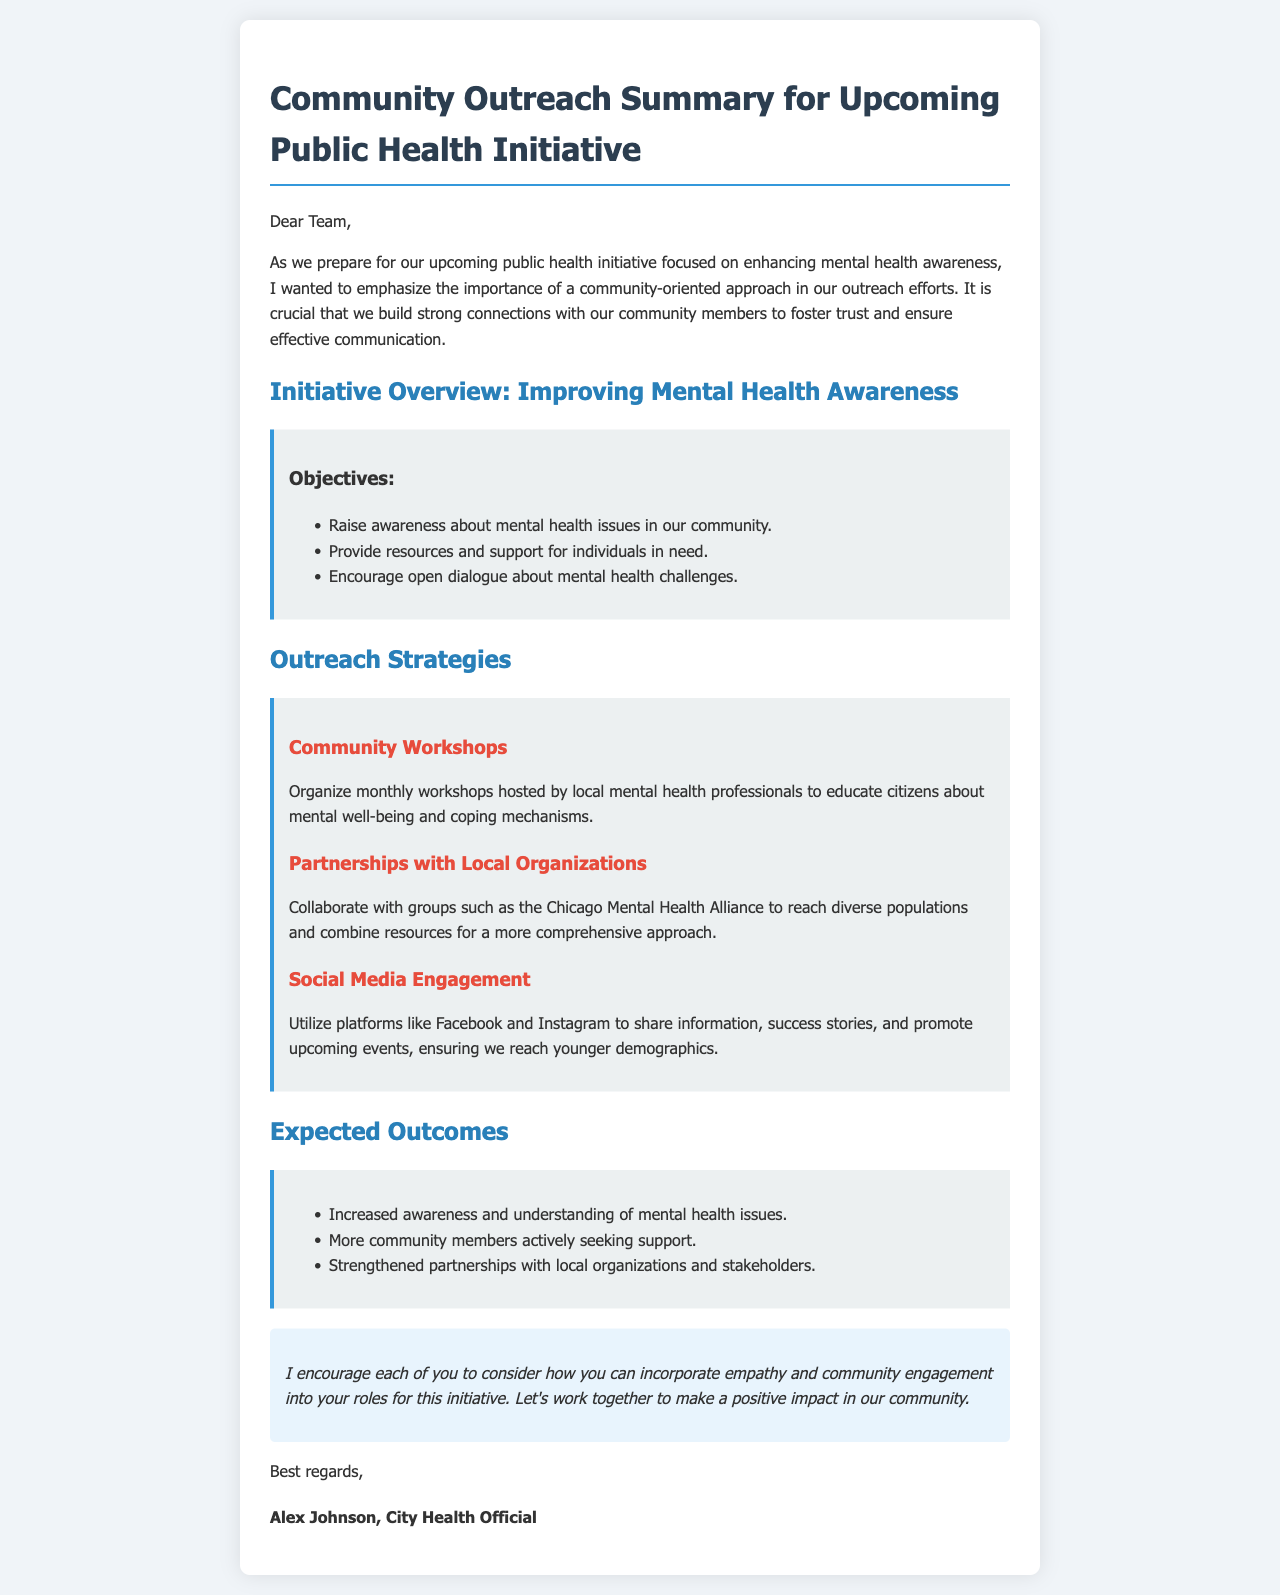What is the title of the initiative? The title of the initiative is specified in the document's header, which is "Community Outreach Summary for Upcoming Public Health Initiative."
Answer: Community Outreach Summary for Upcoming Public Health Initiative Who is the author of the email? The email's closing section contains the author's name, which identifies them as a city health official.
Answer: Alex Johnson What are the three objectives listed in the document? The objectives are detailed in a bullet point format under the "Objectives" section.
Answer: Raise awareness about mental health issues in our community What type of events will be organized monthly as part of outreach strategies? The outreach strategy mentions monthly events organized to educate citizens.
Answer: Community Workshops Which social media platforms are mentioned for engagement? The document specifies particular social media platforms in the outreach strategy section for sharing information.
Answer: Facebook and Instagram What is the expected outcome relating to community support? One expected outcome discusses the action of community members in relation to support.
Answer: More community members actively seeking support How many outreach strategies are outlined in the document? The document lists three outreach strategies under the respective section.
Answer: Three What is the main focus of the upcoming public health initiative? The main focus is noted in the "Initiative Overview" section, indicating the subject matter of the initiative.
Answer: Improving Mental Health Awareness What tone does the author suggest for interacting with the community? The author concludes the email emphasizing the importance of a particular approach in their roles.
Answer: Empathy and community engagement 